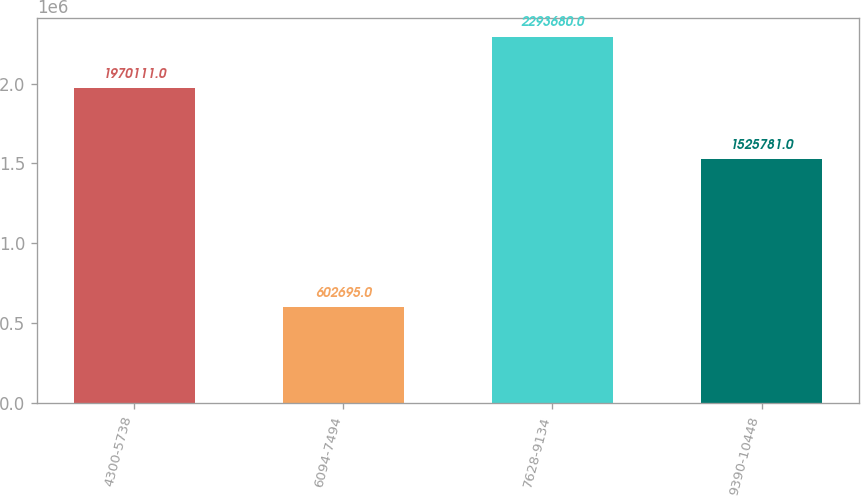Convert chart. <chart><loc_0><loc_0><loc_500><loc_500><bar_chart><fcel>4300-5738<fcel>6094-7494<fcel>7628-9134<fcel>9390-10448<nl><fcel>1.97011e+06<fcel>602695<fcel>2.29368e+06<fcel>1.52578e+06<nl></chart> 